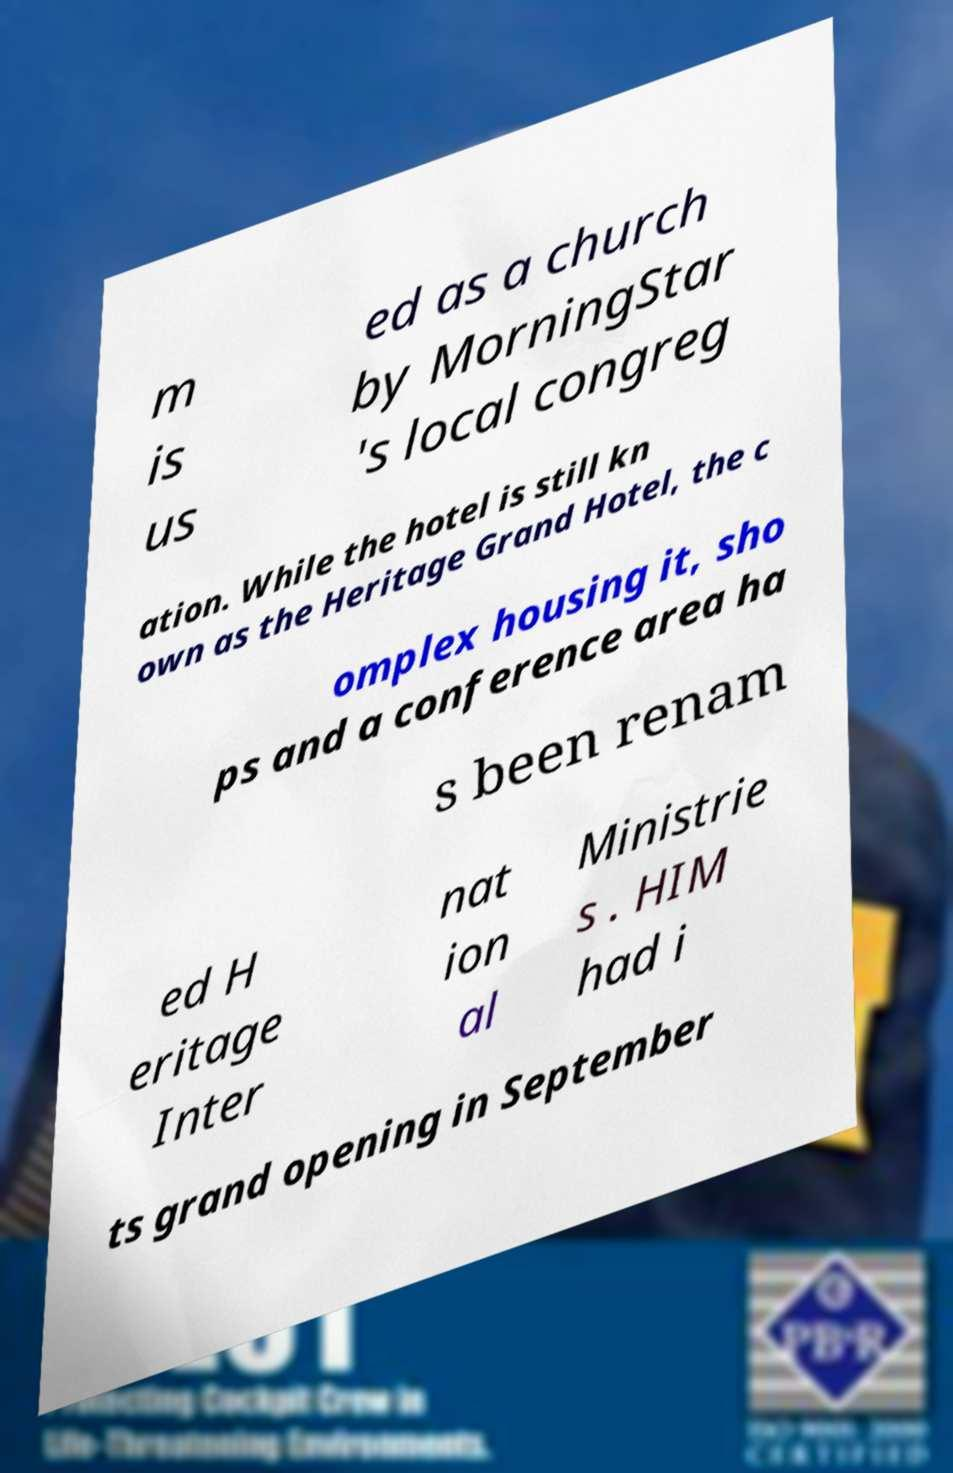There's text embedded in this image that I need extracted. Can you transcribe it verbatim? m is us ed as a church by MorningStar 's local congreg ation. While the hotel is still kn own as the Heritage Grand Hotel, the c omplex housing it, sho ps and a conference area ha s been renam ed H eritage Inter nat ion al Ministrie s . HIM had i ts grand opening in September 